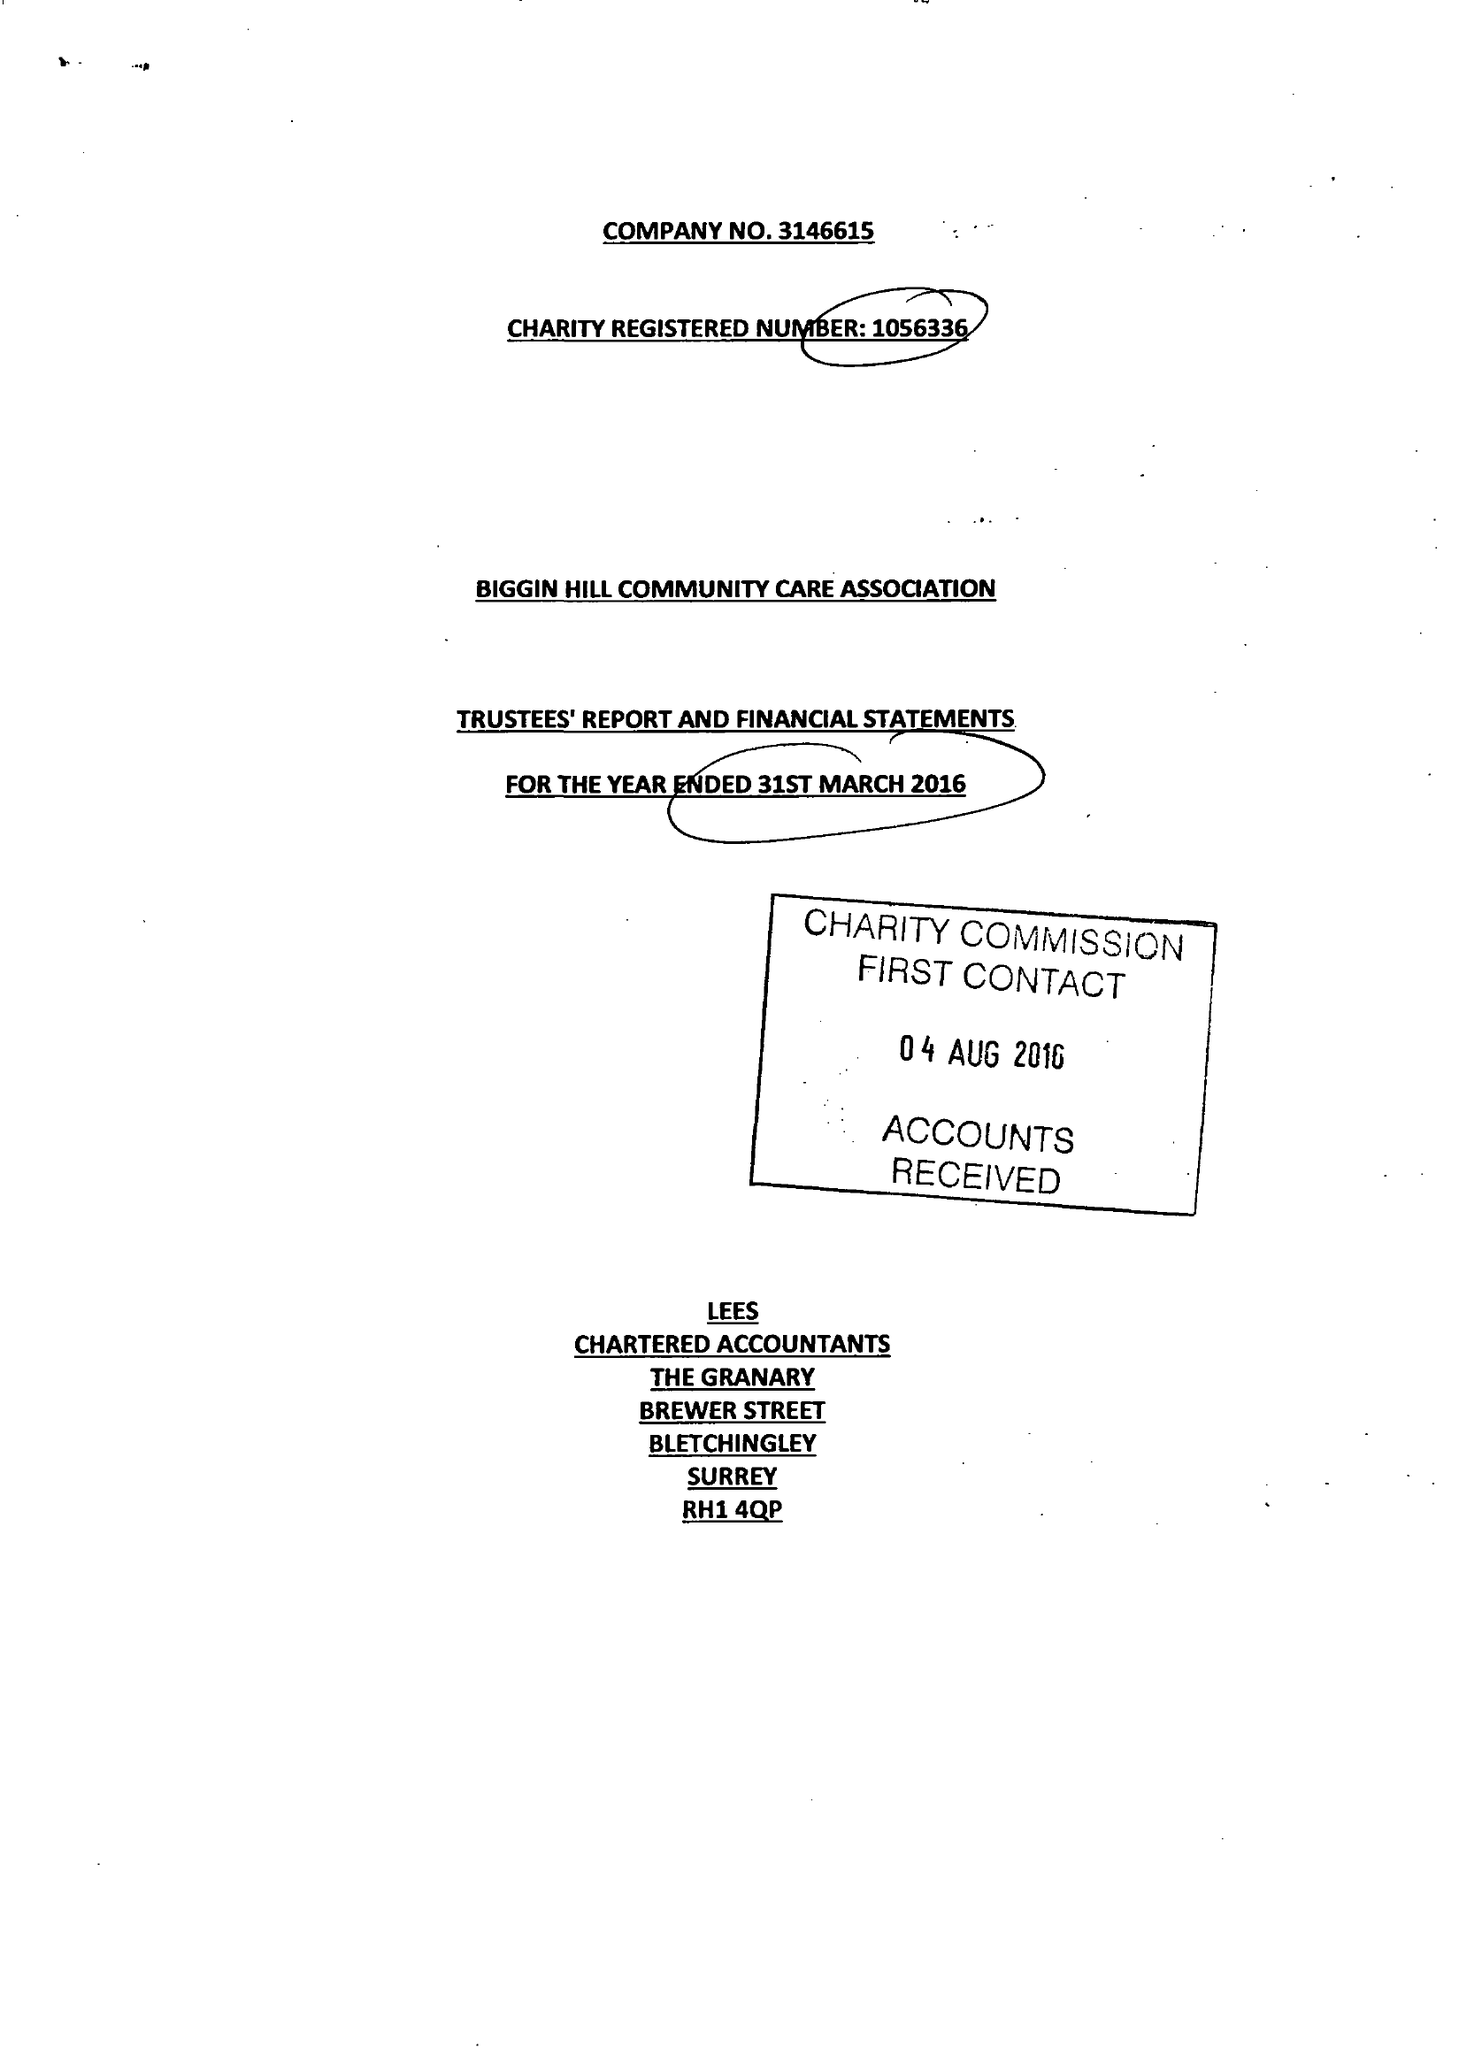What is the value for the report_date?
Answer the question using a single word or phrase. 2016-03-31 